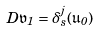Convert formula to latex. <formula><loc_0><loc_0><loc_500><loc_500>D \mathfrak { v } _ { 1 } = \delta ^ { j } _ { s } ( \mathfrak { u } _ { 0 } )</formula> 